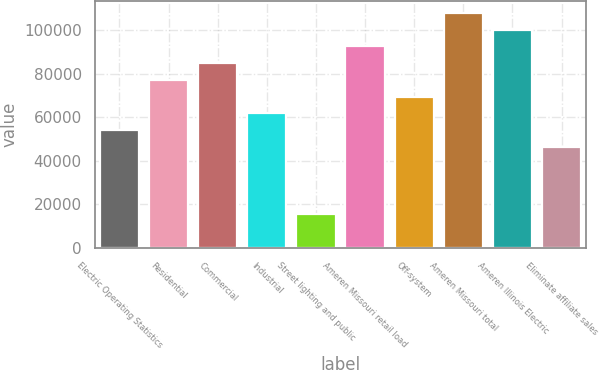<chart> <loc_0><loc_0><loc_500><loc_500><bar_chart><fcel>Electric Operating Statistics<fcel>Residential<fcel>Commercial<fcel>Industrial<fcel>Street lighting and public<fcel>Ameren Missouri retail load<fcel>Off-system<fcel>Ameren Missouri total<fcel>Ameren Illinois Electric<fcel>Eliminate affiliate sales<nl><fcel>54016.1<fcel>77141<fcel>84849.3<fcel>61724.4<fcel>15474.6<fcel>92557.6<fcel>69432.7<fcel>107974<fcel>100266<fcel>46307.8<nl></chart> 